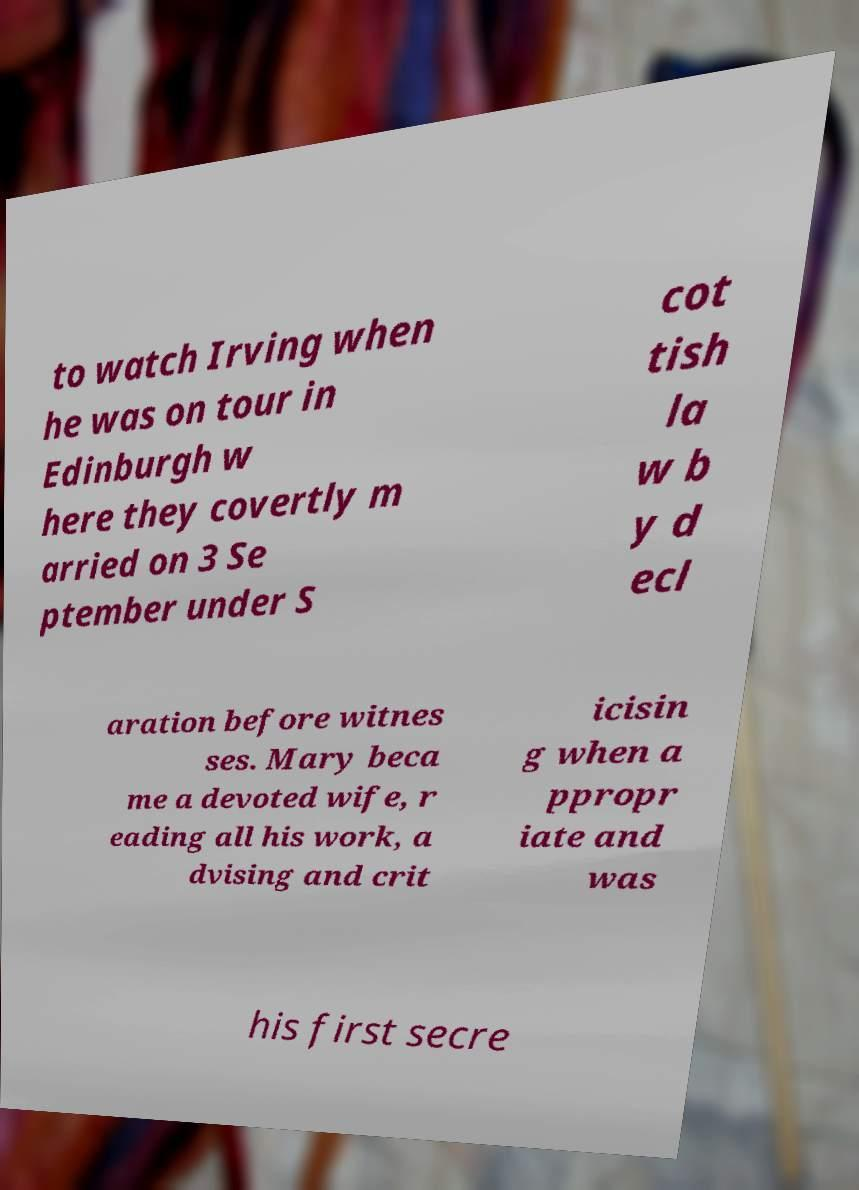For documentation purposes, I need the text within this image transcribed. Could you provide that? to watch Irving when he was on tour in Edinburgh w here they covertly m arried on 3 Se ptember under S cot tish la w b y d ecl aration before witnes ses. Mary beca me a devoted wife, r eading all his work, a dvising and crit icisin g when a ppropr iate and was his first secre 